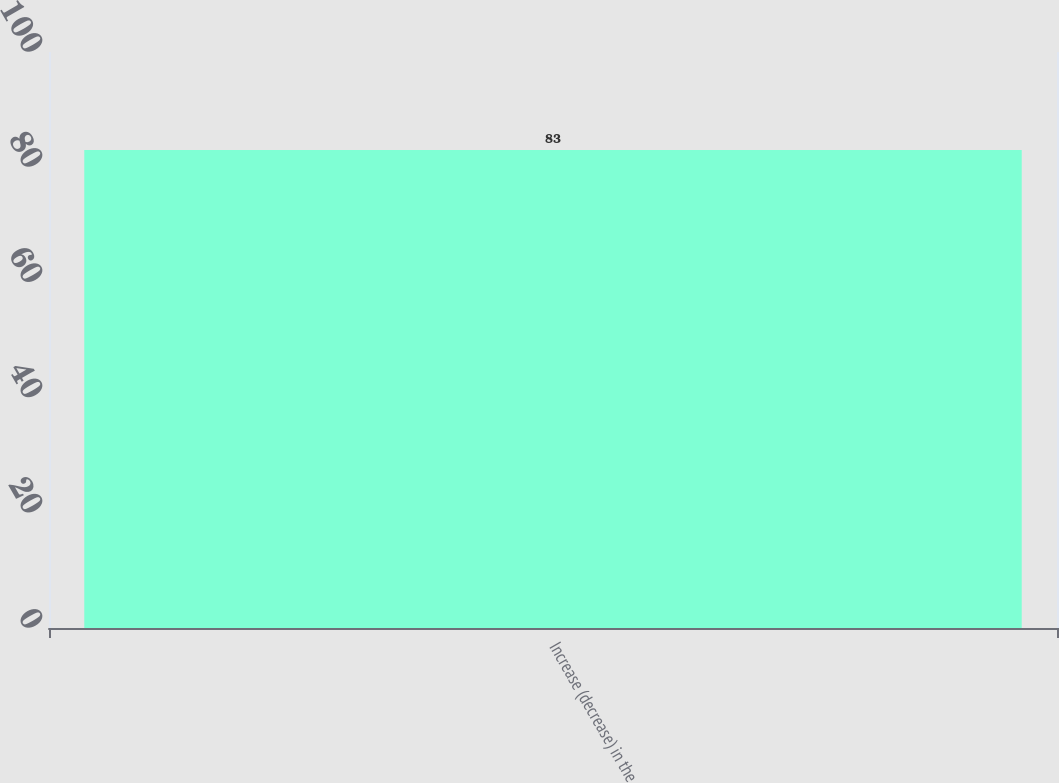Convert chart to OTSL. <chart><loc_0><loc_0><loc_500><loc_500><bar_chart><fcel>Increase (decrease) in the<nl><fcel>83<nl></chart> 